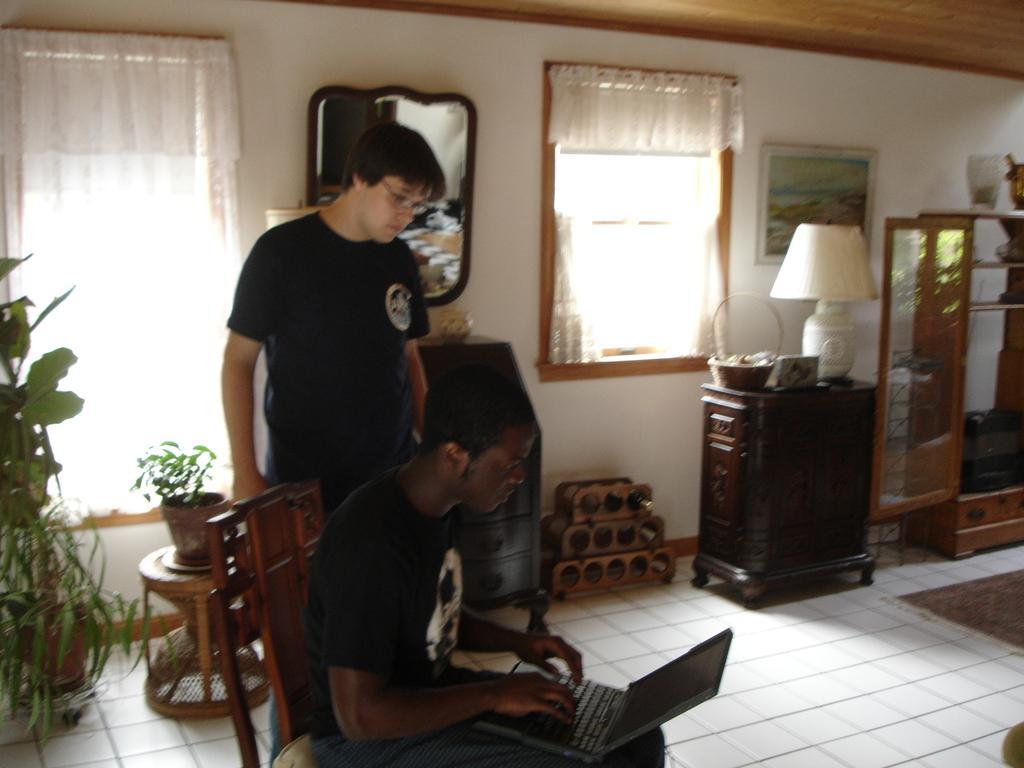Describe this image in one or two sentences. The picture is taken in a closed room in which there is only two people and one person is sitting in the chair in black dress and operating laptop and another is standing behind him in black dress and behind the people there is a wall with windows and curtains and big mirror and photos on it and at the left corner of the picture there are plants and at the right corner of the picture there is one table on which a basket and a bed lamp is present and at the corner there is one wardrobe made of wooden and there is one wine rack. 